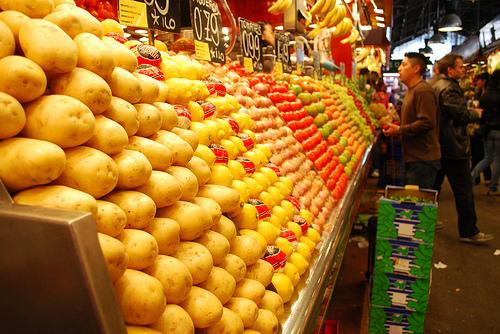In the image, list the different types of fruits and vegetables present and how they are arranged. Golden yellow potatoes are nicely arranged, red tomatoes in the middle, and yellow bunches of bananas hanging; lemons are stacked. Point out a few items related to the market store and their locations. Bananas hang above the vegetable stand, lemons are next to potatoes, and red tomatoes are in the middle of the stand. Narrate the lighting and cleanliness situation in the image. There's a dark light illuminating the walkway, with circular lamps in the store, and there are 3 pieces of trash on the sidewalk. Briefly describe the store's interior, focusing on the lights and any other fixtures. The store has circular lamps, a light hanging from the ceiling, and three lights on the eave. Mention the main elements and colors present in the image. The image features golden yellow potatoes, red tomatoes, green boxes, a man in a black leather jacket, a brown shirt, and fruit like bananas and lemons. State a few details about the footwear and belongings of the man in the image. The man is wearing gray shoes with white shoelaces, and his left hand is visible, holding a red pepper. Name a few objects and locations found in the image. There are yellow potatoes, red tomatoes, green cardboard boxes, bananas hanging atop the store, and a man looking at food. Describe any text or numbers visible in the image and where they can be found. The number "079" is written on a board, and there are four signs above the vegetable stand with the prices. Explain the scene in the image, focusing on the market's organization and appearance. A well-organized vegetables and fruits market with nicely-arranged potatoes, lemons, and red tomatoes; signs showing prices on top. Describe what the man in the image is wearing and doing. The man is wearing a black leather jacket and a brown shirt, and he is holding a red pepper while looking at the food. 